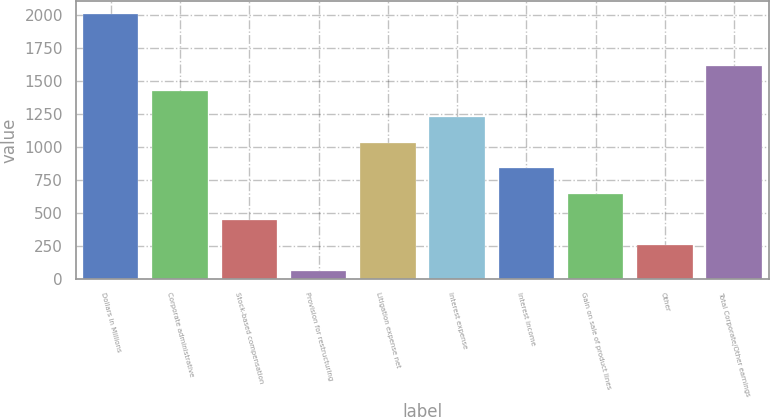Convert chart. <chart><loc_0><loc_0><loc_500><loc_500><bar_chart><fcel>Dollars in Millions<fcel>Corporate administrative<fcel>Stock-based compensation<fcel>Provision for restructuring<fcel>Litigation expense net<fcel>Interest expense<fcel>Interest income<fcel>Gain on sale of product lines<fcel>Other<fcel>Total Corporate/Other earnings<nl><fcel>2006<fcel>1421.9<fcel>448.4<fcel>59<fcel>1032.5<fcel>1227.2<fcel>837.8<fcel>643.1<fcel>253.7<fcel>1616.6<nl></chart> 